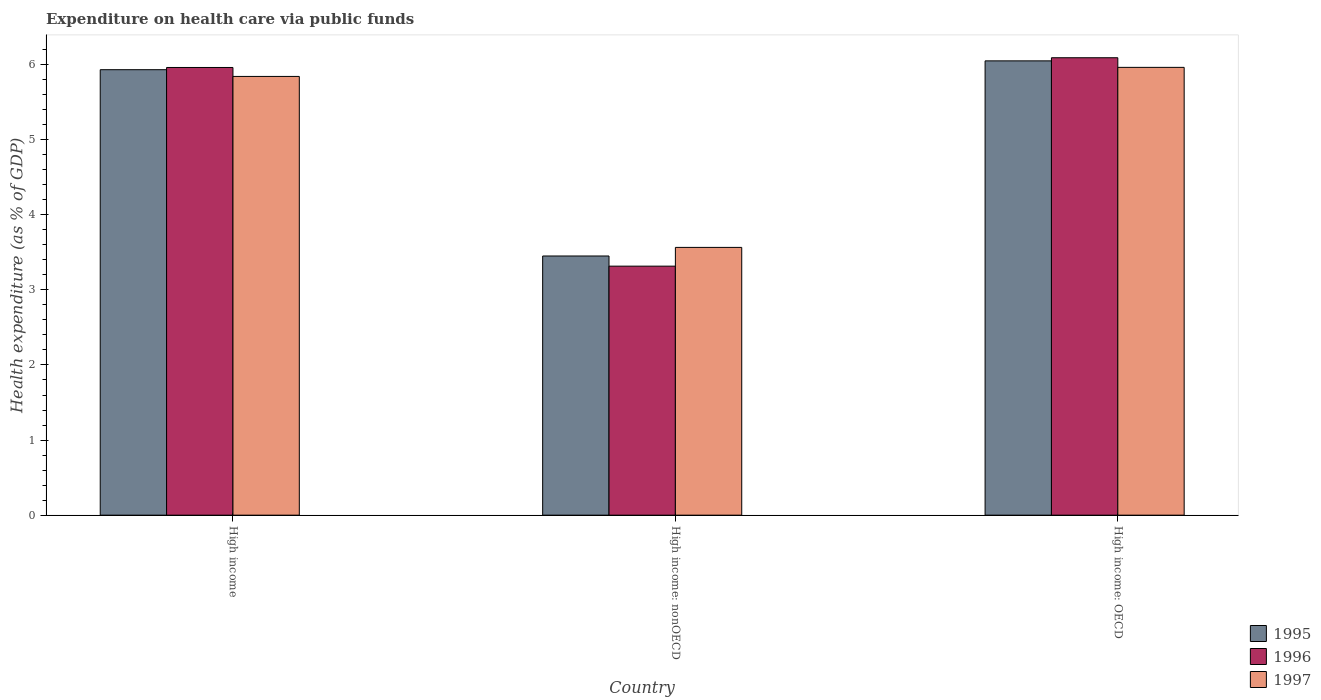How many groups of bars are there?
Your answer should be very brief. 3. Are the number of bars on each tick of the X-axis equal?
Your response must be concise. Yes. How many bars are there on the 2nd tick from the left?
Make the answer very short. 3. How many bars are there on the 1st tick from the right?
Give a very brief answer. 3. What is the label of the 3rd group of bars from the left?
Offer a very short reply. High income: OECD. What is the expenditure made on health care in 1997 in High income: OECD?
Your response must be concise. 5.96. Across all countries, what is the maximum expenditure made on health care in 1996?
Your response must be concise. 6.09. Across all countries, what is the minimum expenditure made on health care in 1997?
Offer a terse response. 3.57. In which country was the expenditure made on health care in 1997 maximum?
Your answer should be very brief. High income: OECD. In which country was the expenditure made on health care in 1996 minimum?
Ensure brevity in your answer.  High income: nonOECD. What is the total expenditure made on health care in 1996 in the graph?
Provide a succinct answer. 15.37. What is the difference between the expenditure made on health care in 1995 in High income and that in High income: nonOECD?
Provide a succinct answer. 2.48. What is the difference between the expenditure made on health care in 1997 in High income: nonOECD and the expenditure made on health care in 1995 in High income?
Keep it short and to the point. -2.37. What is the average expenditure made on health care in 1995 per country?
Ensure brevity in your answer.  5.14. What is the difference between the expenditure made on health care of/in 1995 and expenditure made on health care of/in 1997 in High income: OECD?
Keep it short and to the point. 0.09. In how many countries, is the expenditure made on health care in 1997 greater than 1.6 %?
Your answer should be compact. 3. What is the ratio of the expenditure made on health care in 1996 in High income to that in High income: OECD?
Your answer should be compact. 0.98. What is the difference between the highest and the second highest expenditure made on health care in 1997?
Your answer should be compact. 2.28. What is the difference between the highest and the lowest expenditure made on health care in 1996?
Your answer should be very brief. 2.78. In how many countries, is the expenditure made on health care in 1996 greater than the average expenditure made on health care in 1996 taken over all countries?
Your answer should be very brief. 2. What does the 2nd bar from the left in High income represents?
Offer a very short reply. 1996. Is it the case that in every country, the sum of the expenditure made on health care in 1997 and expenditure made on health care in 1996 is greater than the expenditure made on health care in 1995?
Provide a short and direct response. Yes. How many bars are there?
Provide a succinct answer. 9. Are all the bars in the graph horizontal?
Give a very brief answer. No. What is the difference between two consecutive major ticks on the Y-axis?
Give a very brief answer. 1. Does the graph contain any zero values?
Offer a terse response. No. Does the graph contain grids?
Make the answer very short. No. How are the legend labels stacked?
Offer a terse response. Vertical. What is the title of the graph?
Your answer should be very brief. Expenditure on health care via public funds. Does "1978" appear as one of the legend labels in the graph?
Your answer should be compact. No. What is the label or title of the X-axis?
Your answer should be compact. Country. What is the label or title of the Y-axis?
Offer a very short reply. Health expenditure (as % of GDP). What is the Health expenditure (as % of GDP) in 1995 in High income?
Your answer should be compact. 5.93. What is the Health expenditure (as % of GDP) in 1996 in High income?
Your answer should be very brief. 5.96. What is the Health expenditure (as % of GDP) of 1997 in High income?
Your response must be concise. 5.84. What is the Health expenditure (as % of GDP) of 1995 in High income: nonOECD?
Offer a terse response. 3.45. What is the Health expenditure (as % of GDP) in 1996 in High income: nonOECD?
Provide a short and direct response. 3.32. What is the Health expenditure (as % of GDP) of 1997 in High income: nonOECD?
Provide a succinct answer. 3.57. What is the Health expenditure (as % of GDP) in 1995 in High income: OECD?
Your answer should be very brief. 6.05. What is the Health expenditure (as % of GDP) of 1996 in High income: OECD?
Your answer should be very brief. 6.09. What is the Health expenditure (as % of GDP) of 1997 in High income: OECD?
Your response must be concise. 5.96. Across all countries, what is the maximum Health expenditure (as % of GDP) in 1995?
Provide a succinct answer. 6.05. Across all countries, what is the maximum Health expenditure (as % of GDP) in 1996?
Offer a terse response. 6.09. Across all countries, what is the maximum Health expenditure (as % of GDP) in 1997?
Your answer should be very brief. 5.96. Across all countries, what is the minimum Health expenditure (as % of GDP) of 1995?
Provide a succinct answer. 3.45. Across all countries, what is the minimum Health expenditure (as % of GDP) in 1996?
Your response must be concise. 3.32. Across all countries, what is the minimum Health expenditure (as % of GDP) of 1997?
Provide a short and direct response. 3.57. What is the total Health expenditure (as % of GDP) in 1995 in the graph?
Provide a succinct answer. 15.43. What is the total Health expenditure (as % of GDP) in 1996 in the graph?
Keep it short and to the point. 15.37. What is the total Health expenditure (as % of GDP) of 1997 in the graph?
Your answer should be very brief. 15.37. What is the difference between the Health expenditure (as % of GDP) of 1995 in High income and that in High income: nonOECD?
Provide a succinct answer. 2.48. What is the difference between the Health expenditure (as % of GDP) in 1996 in High income and that in High income: nonOECD?
Your response must be concise. 2.65. What is the difference between the Health expenditure (as % of GDP) of 1997 in High income and that in High income: nonOECD?
Your answer should be compact. 2.28. What is the difference between the Health expenditure (as % of GDP) of 1995 in High income and that in High income: OECD?
Your answer should be compact. -0.12. What is the difference between the Health expenditure (as % of GDP) in 1996 in High income and that in High income: OECD?
Provide a short and direct response. -0.13. What is the difference between the Health expenditure (as % of GDP) in 1997 in High income and that in High income: OECD?
Offer a terse response. -0.12. What is the difference between the Health expenditure (as % of GDP) of 1995 in High income: nonOECD and that in High income: OECD?
Ensure brevity in your answer.  -2.6. What is the difference between the Health expenditure (as % of GDP) of 1996 in High income: nonOECD and that in High income: OECD?
Your response must be concise. -2.77. What is the difference between the Health expenditure (as % of GDP) in 1997 in High income: nonOECD and that in High income: OECD?
Offer a very short reply. -2.4. What is the difference between the Health expenditure (as % of GDP) in 1995 in High income and the Health expenditure (as % of GDP) in 1996 in High income: nonOECD?
Your answer should be very brief. 2.62. What is the difference between the Health expenditure (as % of GDP) of 1995 in High income and the Health expenditure (as % of GDP) of 1997 in High income: nonOECD?
Offer a very short reply. 2.37. What is the difference between the Health expenditure (as % of GDP) in 1996 in High income and the Health expenditure (as % of GDP) in 1997 in High income: nonOECD?
Ensure brevity in your answer.  2.4. What is the difference between the Health expenditure (as % of GDP) in 1995 in High income and the Health expenditure (as % of GDP) in 1996 in High income: OECD?
Your answer should be very brief. -0.16. What is the difference between the Health expenditure (as % of GDP) in 1995 in High income and the Health expenditure (as % of GDP) in 1997 in High income: OECD?
Offer a very short reply. -0.03. What is the difference between the Health expenditure (as % of GDP) in 1996 in High income and the Health expenditure (as % of GDP) in 1997 in High income: OECD?
Provide a succinct answer. -0. What is the difference between the Health expenditure (as % of GDP) of 1995 in High income: nonOECD and the Health expenditure (as % of GDP) of 1996 in High income: OECD?
Provide a succinct answer. -2.64. What is the difference between the Health expenditure (as % of GDP) of 1995 in High income: nonOECD and the Health expenditure (as % of GDP) of 1997 in High income: OECD?
Ensure brevity in your answer.  -2.51. What is the difference between the Health expenditure (as % of GDP) of 1996 in High income: nonOECD and the Health expenditure (as % of GDP) of 1997 in High income: OECD?
Your answer should be very brief. -2.65. What is the average Health expenditure (as % of GDP) in 1995 per country?
Give a very brief answer. 5.14. What is the average Health expenditure (as % of GDP) of 1996 per country?
Your answer should be very brief. 5.12. What is the average Health expenditure (as % of GDP) in 1997 per country?
Provide a succinct answer. 5.12. What is the difference between the Health expenditure (as % of GDP) of 1995 and Health expenditure (as % of GDP) of 1996 in High income?
Give a very brief answer. -0.03. What is the difference between the Health expenditure (as % of GDP) of 1995 and Health expenditure (as % of GDP) of 1997 in High income?
Offer a very short reply. 0.09. What is the difference between the Health expenditure (as % of GDP) of 1996 and Health expenditure (as % of GDP) of 1997 in High income?
Offer a terse response. 0.12. What is the difference between the Health expenditure (as % of GDP) in 1995 and Health expenditure (as % of GDP) in 1996 in High income: nonOECD?
Give a very brief answer. 0.14. What is the difference between the Health expenditure (as % of GDP) in 1995 and Health expenditure (as % of GDP) in 1997 in High income: nonOECD?
Offer a terse response. -0.11. What is the difference between the Health expenditure (as % of GDP) in 1996 and Health expenditure (as % of GDP) in 1997 in High income: nonOECD?
Give a very brief answer. -0.25. What is the difference between the Health expenditure (as % of GDP) of 1995 and Health expenditure (as % of GDP) of 1996 in High income: OECD?
Ensure brevity in your answer.  -0.04. What is the difference between the Health expenditure (as % of GDP) of 1995 and Health expenditure (as % of GDP) of 1997 in High income: OECD?
Your answer should be very brief. 0.09. What is the difference between the Health expenditure (as % of GDP) in 1996 and Health expenditure (as % of GDP) in 1997 in High income: OECD?
Make the answer very short. 0.13. What is the ratio of the Health expenditure (as % of GDP) of 1995 in High income to that in High income: nonOECD?
Offer a very short reply. 1.72. What is the ratio of the Health expenditure (as % of GDP) of 1996 in High income to that in High income: nonOECD?
Offer a very short reply. 1.8. What is the ratio of the Health expenditure (as % of GDP) of 1997 in High income to that in High income: nonOECD?
Provide a succinct answer. 1.64. What is the ratio of the Health expenditure (as % of GDP) in 1995 in High income to that in High income: OECD?
Provide a succinct answer. 0.98. What is the ratio of the Health expenditure (as % of GDP) of 1996 in High income to that in High income: OECD?
Provide a short and direct response. 0.98. What is the ratio of the Health expenditure (as % of GDP) of 1997 in High income to that in High income: OECD?
Your answer should be compact. 0.98. What is the ratio of the Health expenditure (as % of GDP) in 1995 in High income: nonOECD to that in High income: OECD?
Make the answer very short. 0.57. What is the ratio of the Health expenditure (as % of GDP) in 1996 in High income: nonOECD to that in High income: OECD?
Your response must be concise. 0.54. What is the ratio of the Health expenditure (as % of GDP) in 1997 in High income: nonOECD to that in High income: OECD?
Keep it short and to the point. 0.6. What is the difference between the highest and the second highest Health expenditure (as % of GDP) of 1995?
Offer a terse response. 0.12. What is the difference between the highest and the second highest Health expenditure (as % of GDP) in 1996?
Your answer should be compact. 0.13. What is the difference between the highest and the second highest Health expenditure (as % of GDP) of 1997?
Provide a short and direct response. 0.12. What is the difference between the highest and the lowest Health expenditure (as % of GDP) in 1995?
Your answer should be compact. 2.6. What is the difference between the highest and the lowest Health expenditure (as % of GDP) in 1996?
Your answer should be compact. 2.77. What is the difference between the highest and the lowest Health expenditure (as % of GDP) in 1997?
Offer a very short reply. 2.4. 